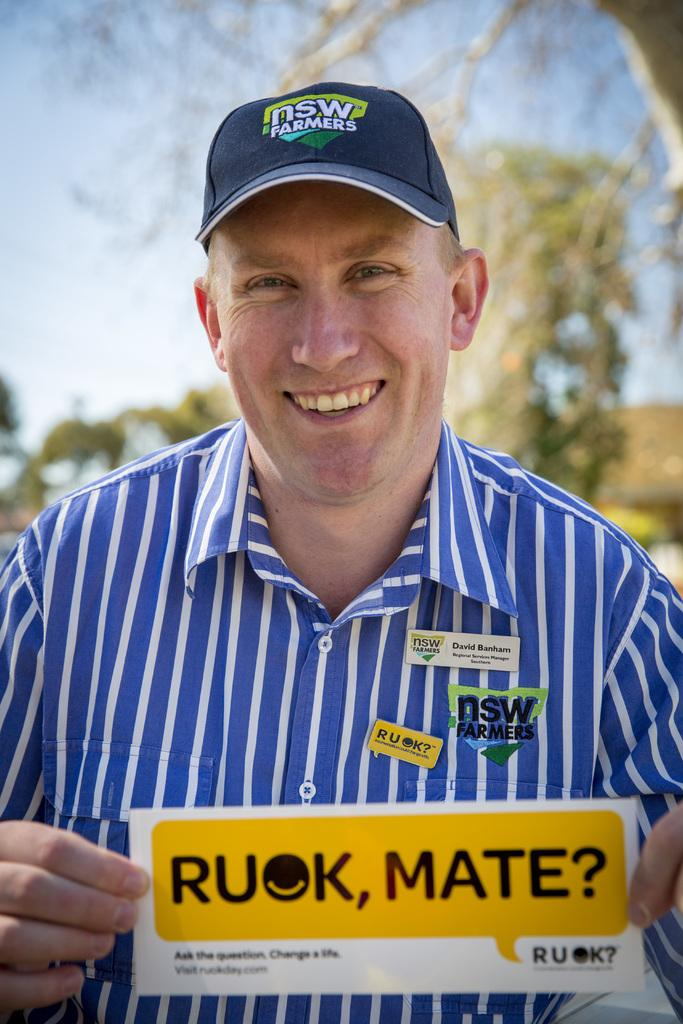<image>
Offer a succinct explanation of the picture presented. A middle aged man in a striped, blue shirt is holding a yellow sign that says Ruok, Mate. 